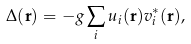Convert formula to latex. <formula><loc_0><loc_0><loc_500><loc_500>\Delta ( \mathbf r ) = - g \sum _ { i } u _ { i } ( \mathbf r ) v _ { i } ^ { * } ( \mathbf r ) ,</formula> 